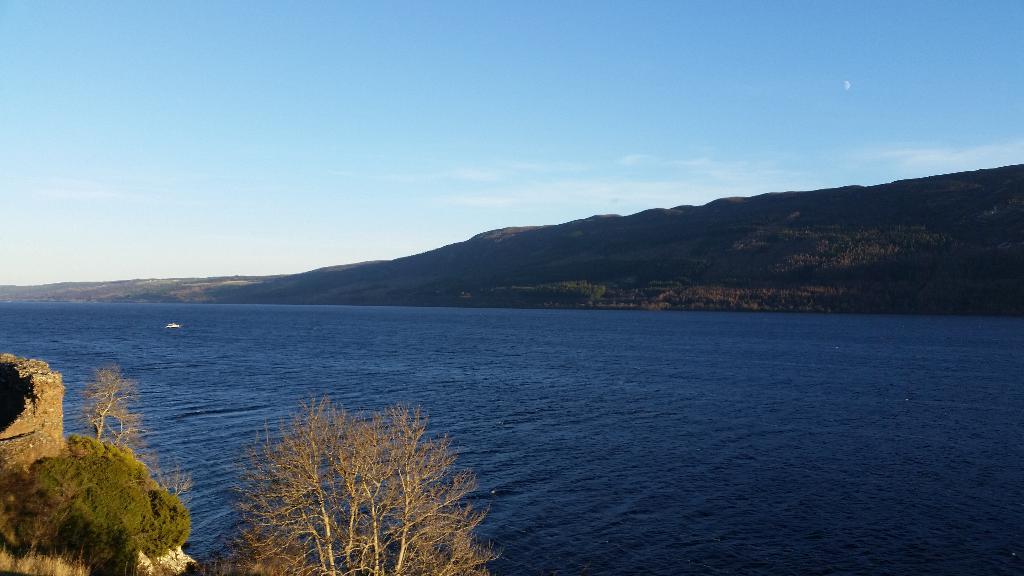Please provide a concise description of this image. On the left side, there are plants and trees on a mountain. On the right side, there is water. In the background, there is a mountain and there are clouds in the blue sky. 